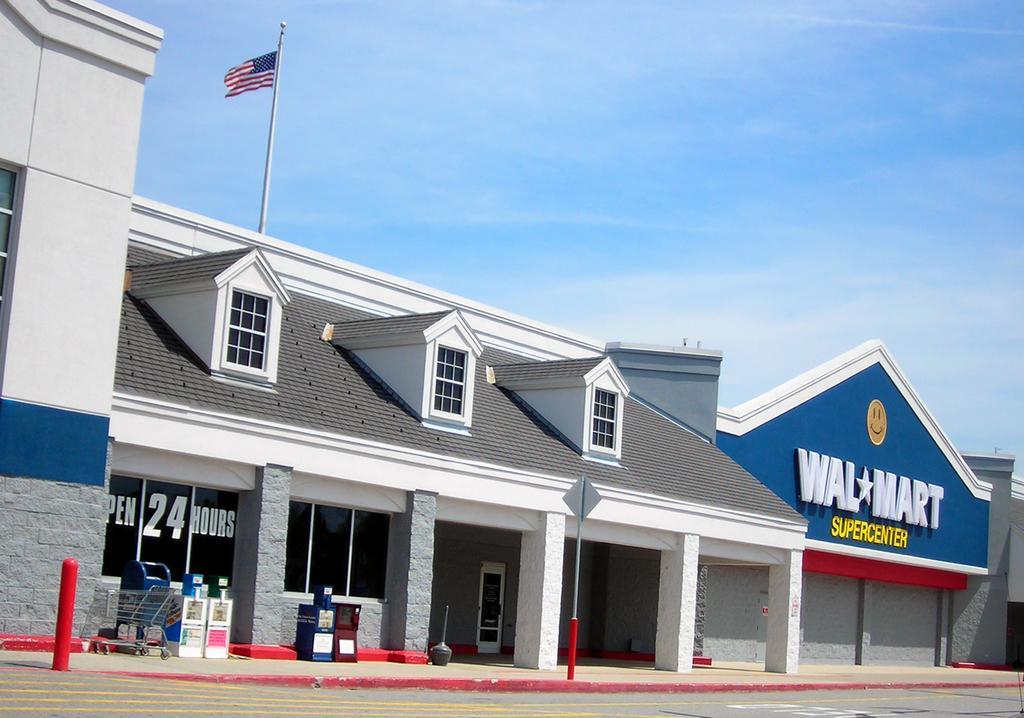Please provide a concise description of this image. In this image, we can see a flag on the Walmart building. There is a sign board beside the road. There is a trolley and trash bins in the bottom left of the image. In the background of the image, there is a sky. 